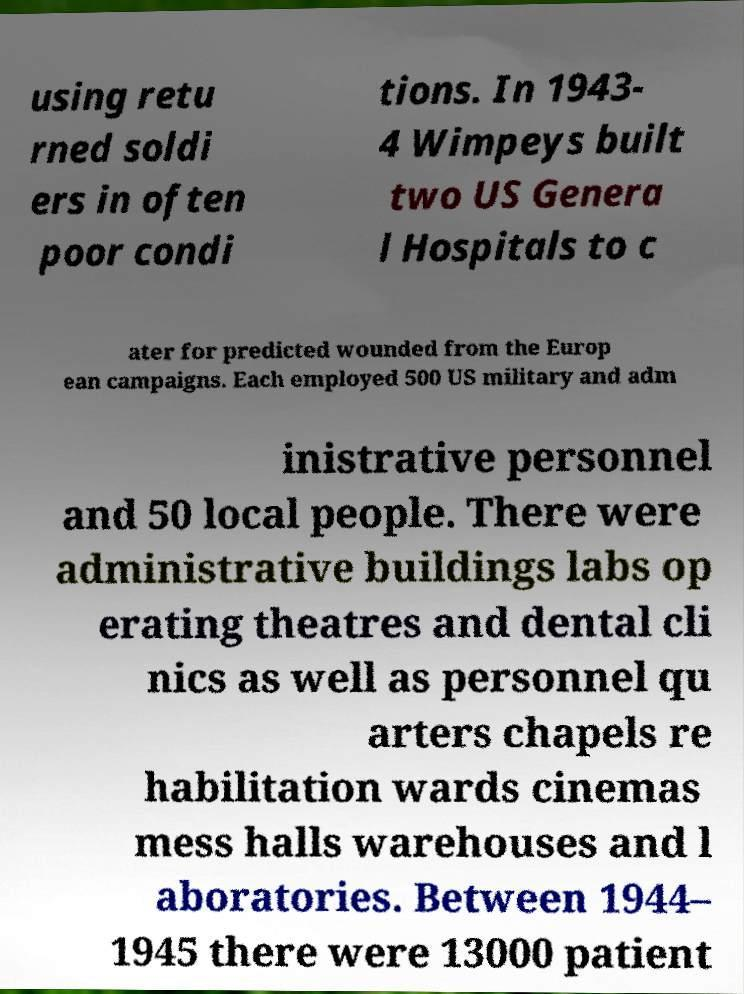For documentation purposes, I need the text within this image transcribed. Could you provide that? using retu rned soldi ers in often poor condi tions. In 1943- 4 Wimpeys built two US Genera l Hospitals to c ater for predicted wounded from the Europ ean campaigns. Each employed 500 US military and adm inistrative personnel and 50 local people. There were administrative buildings labs op erating theatres and dental cli nics as well as personnel qu arters chapels re habilitation wards cinemas mess halls warehouses and l aboratories. Between 1944– 1945 there were 13000 patient 